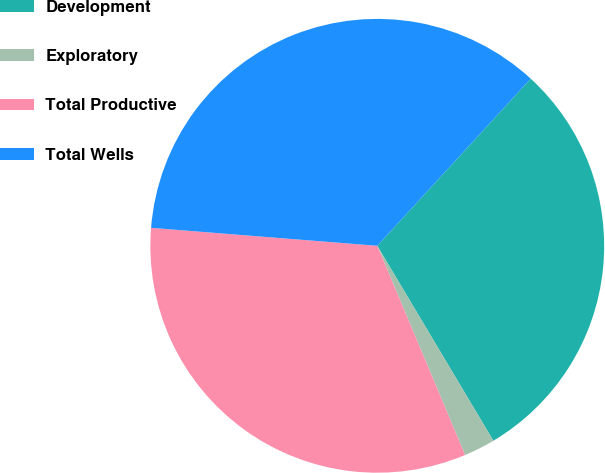Convert chart. <chart><loc_0><loc_0><loc_500><loc_500><pie_chart><fcel>Development<fcel>Exploratory<fcel>Total Productive<fcel>Total Wells<nl><fcel>29.63%<fcel>2.22%<fcel>32.59%<fcel>35.56%<nl></chart> 